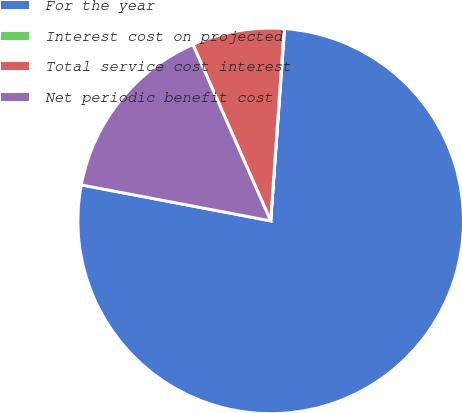Convert chart. <chart><loc_0><loc_0><loc_500><loc_500><pie_chart><fcel>For the year<fcel>Interest cost on projected<fcel>Total service cost interest<fcel>Net periodic benefit cost<nl><fcel>76.84%<fcel>0.04%<fcel>7.72%<fcel>15.4%<nl></chart> 